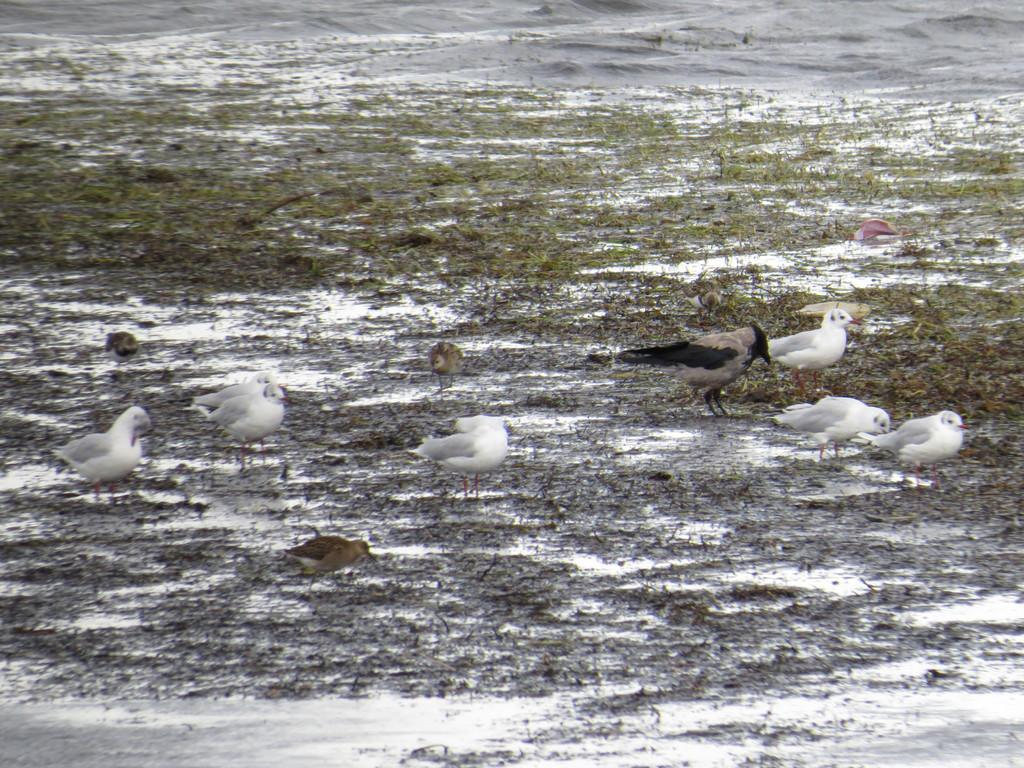What type of animals can be seen in the image? There are birds in the image. What type of vegetation is present in the image? There is grass in the image. What type of winter clothing is the bird wearing in the image? There is no winter clothing present in the image, as it features birds and grass. How does the bird feel about the cold weather in the image? The image does not provide any information about the bird's feelings or the weather conditions. 